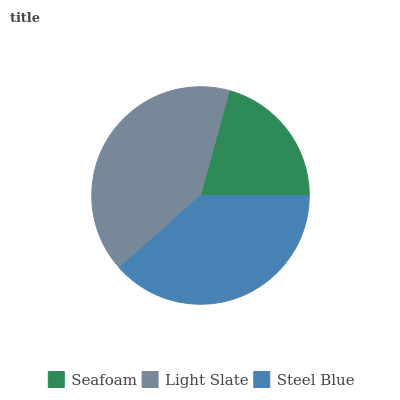Is Seafoam the minimum?
Answer yes or no. Yes. Is Light Slate the maximum?
Answer yes or no. Yes. Is Steel Blue the minimum?
Answer yes or no. No. Is Steel Blue the maximum?
Answer yes or no. No. Is Light Slate greater than Steel Blue?
Answer yes or no. Yes. Is Steel Blue less than Light Slate?
Answer yes or no. Yes. Is Steel Blue greater than Light Slate?
Answer yes or no. No. Is Light Slate less than Steel Blue?
Answer yes or no. No. Is Steel Blue the high median?
Answer yes or no. Yes. Is Steel Blue the low median?
Answer yes or no. Yes. Is Seafoam the high median?
Answer yes or no. No. Is Light Slate the low median?
Answer yes or no. No. 